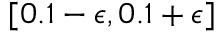Convert formula to latex. <formula><loc_0><loc_0><loc_500><loc_500>[ 0 . 1 - \epsilon , 0 . 1 + \epsilon ]</formula> 